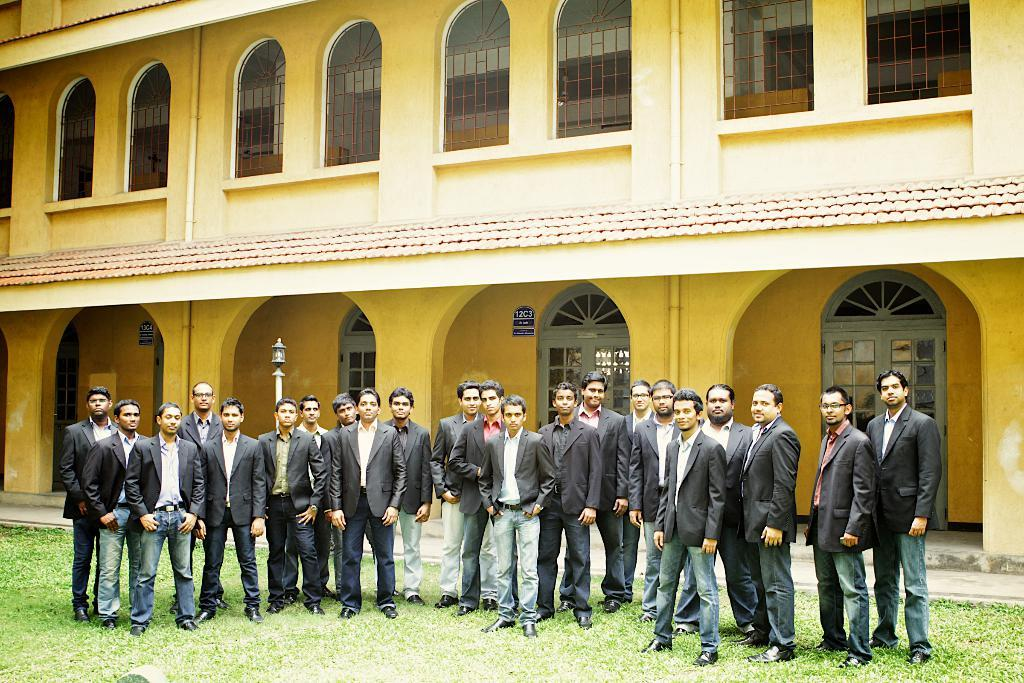What are the people in the image doing? The people in the image are standing on the grass. What can be seen in the background of the image? There is a street light and a building in the image. What feature does the building have? The building has windows. How do the people in the image wash their clothes? There is no information about washing clothes in the image. What type of bottle is visible in the image? There is no bottle present in the image. 